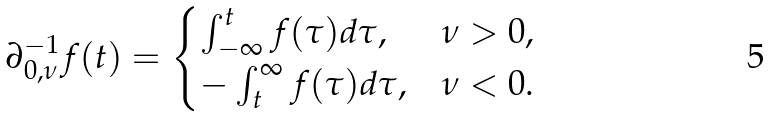<formula> <loc_0><loc_0><loc_500><loc_500>\partial _ { 0 , \nu } ^ { - 1 } f ( t ) = \begin{cases} \int _ { - \infty } ^ { t } f ( \tau ) d \tau , & \nu > 0 , \\ - \int _ { t } ^ { \infty } f ( \tau ) d \tau , & \nu < 0 . \end{cases}</formula> 